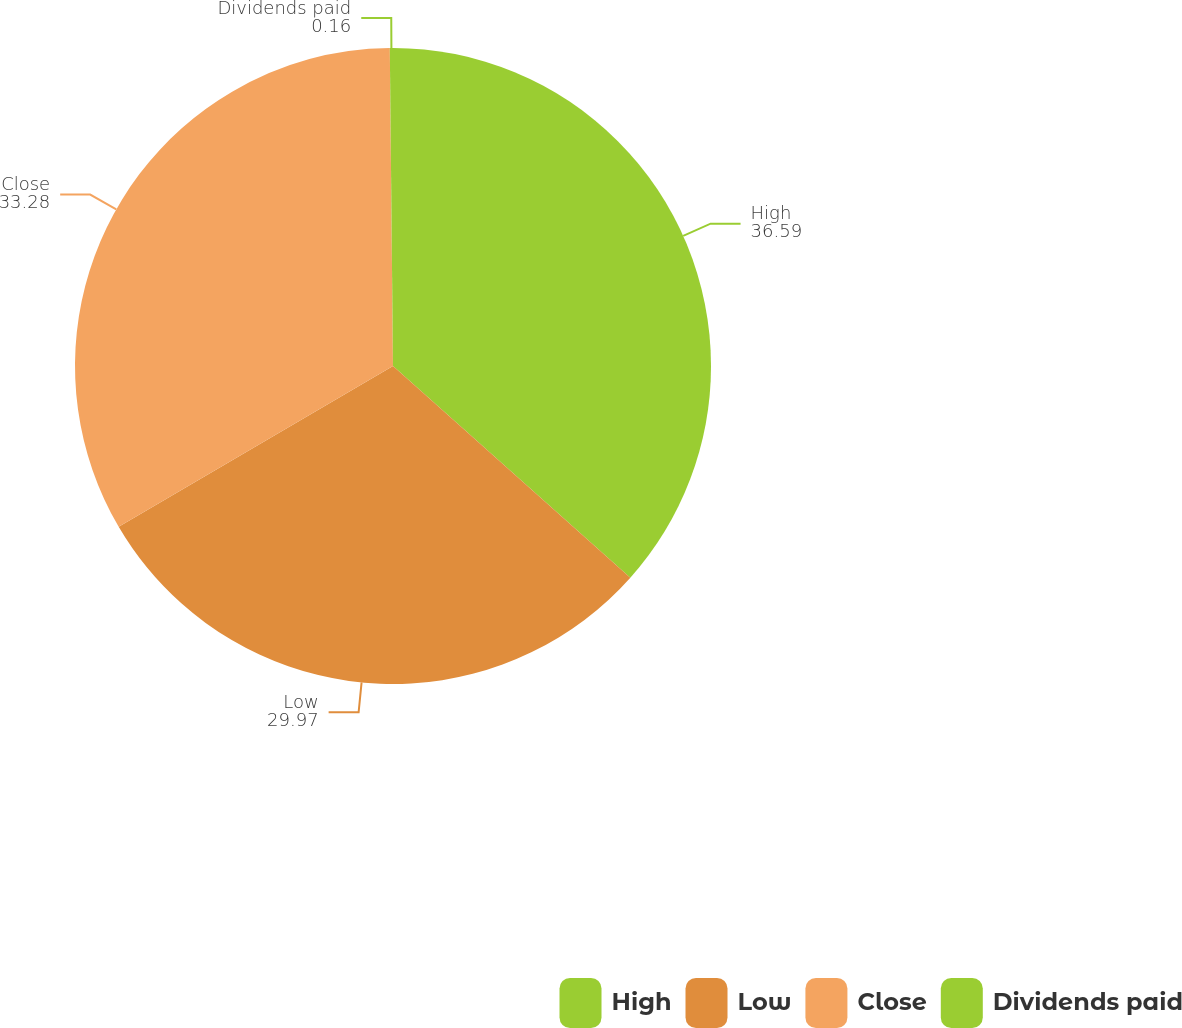<chart> <loc_0><loc_0><loc_500><loc_500><pie_chart><fcel>High<fcel>Low<fcel>Close<fcel>Dividends paid<nl><fcel>36.59%<fcel>29.97%<fcel>33.28%<fcel>0.16%<nl></chart> 